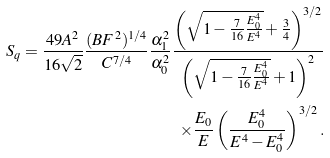<formula> <loc_0><loc_0><loc_500><loc_500>S _ { q } = \frac { 4 9 A ^ { 2 } } { 1 6 \sqrt { 2 } } \frac { ( B F ^ { 2 } ) ^ { 1 / 4 } } { C ^ { 7 / 4 } } \frac { \alpha _ { 1 } ^ { 2 } } { \alpha _ { 0 } ^ { 2 } } \frac { \left ( \sqrt { 1 - \frac { 7 } { 1 6 } \frac { E _ { 0 } ^ { 4 } } { E ^ { 4 } } } + \frac { 3 } { 4 } \right ) ^ { 3 / 2 } } { \left ( \sqrt { 1 - \frac { 7 } { 1 6 } \frac { E _ { 0 } ^ { 4 } } { E ^ { 4 } } } + 1 \right ) ^ { 2 } } \\ \times \frac { E _ { 0 } } { E } \left ( \frac { E _ { 0 } ^ { 4 } } { E ^ { 4 } - E _ { 0 } ^ { 4 } } \right ) ^ { 3 / 2 } .</formula> 